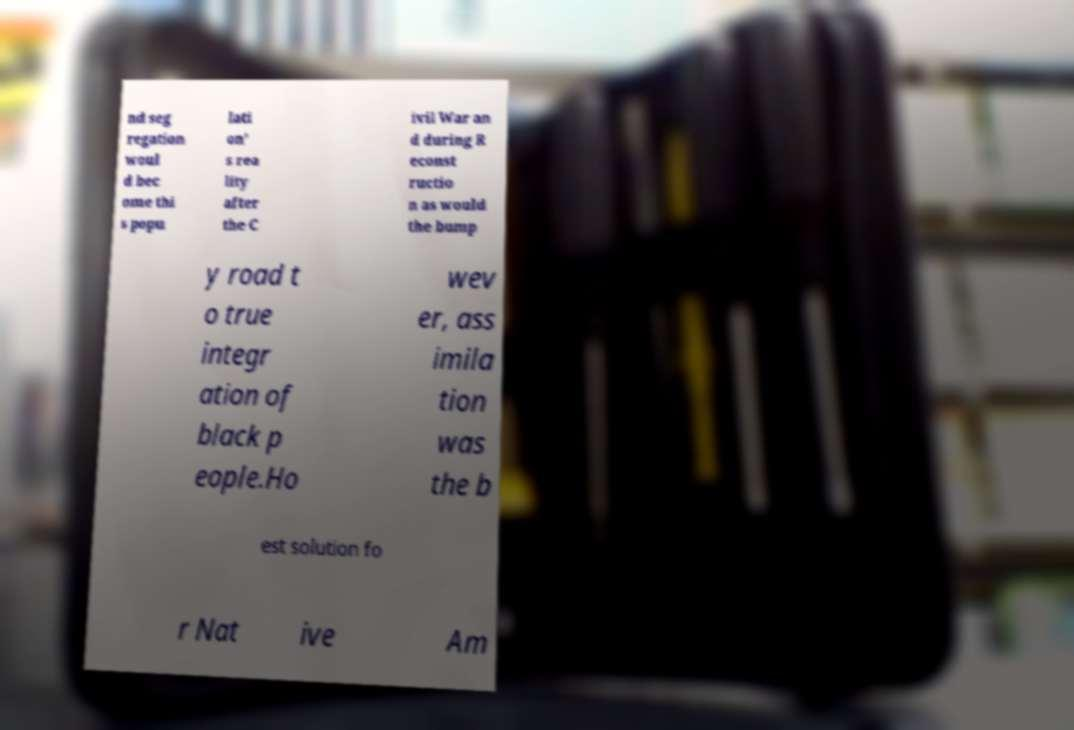I need the written content from this picture converted into text. Can you do that? nd seg regation woul d bec ome thi s popu lati on' s rea lity after the C ivil War an d during R econst ructio n as would the bump y road t o true integr ation of black p eople.Ho wev er, ass imila tion was the b est solution fo r Nat ive Am 